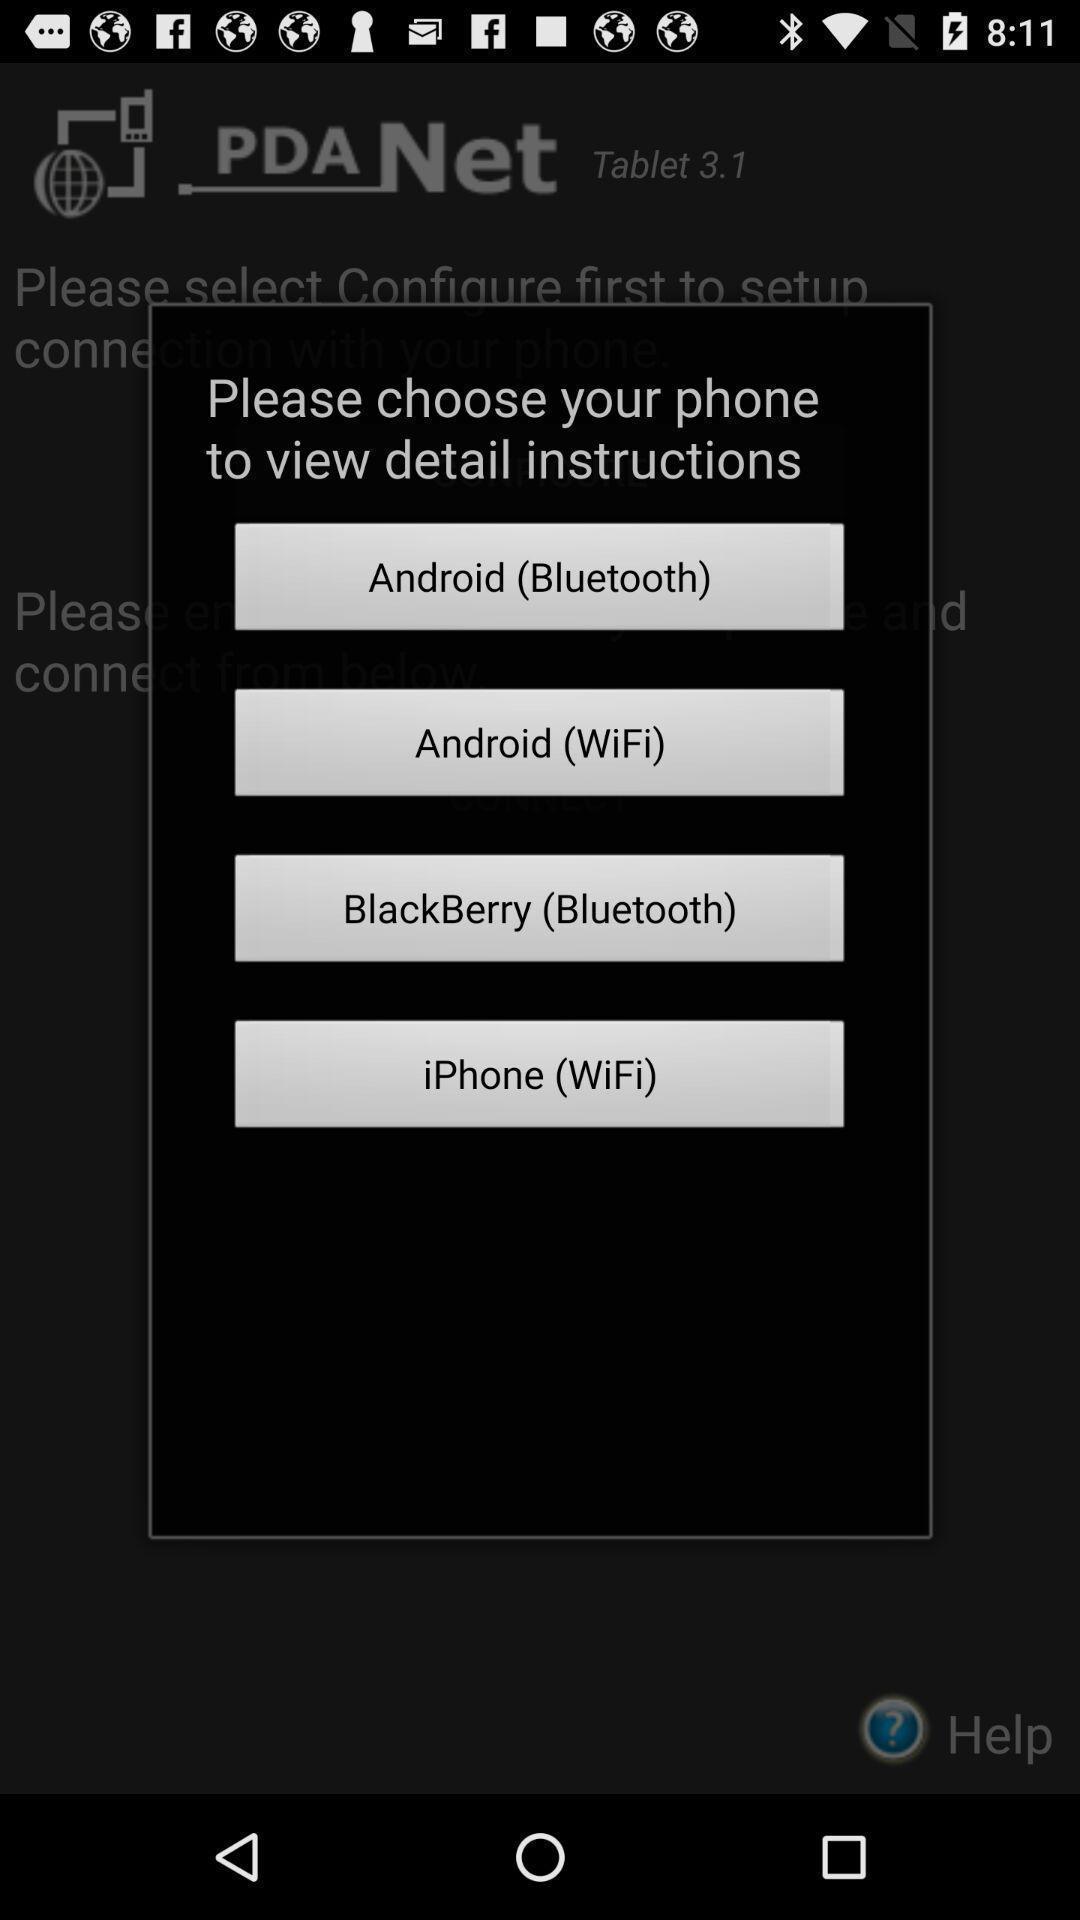Provide a detailed account of this screenshot. Pop-up showing the list of options to view. 